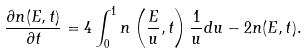<formula> <loc_0><loc_0><loc_500><loc_500>\frac { \partial n ( E , t ) } { \partial t } = 4 \int _ { 0 } ^ { 1 } n \left ( \frac { E } { u } , t \right ) \frac { 1 } { u } d u - 2 n ( E , t ) .</formula> 